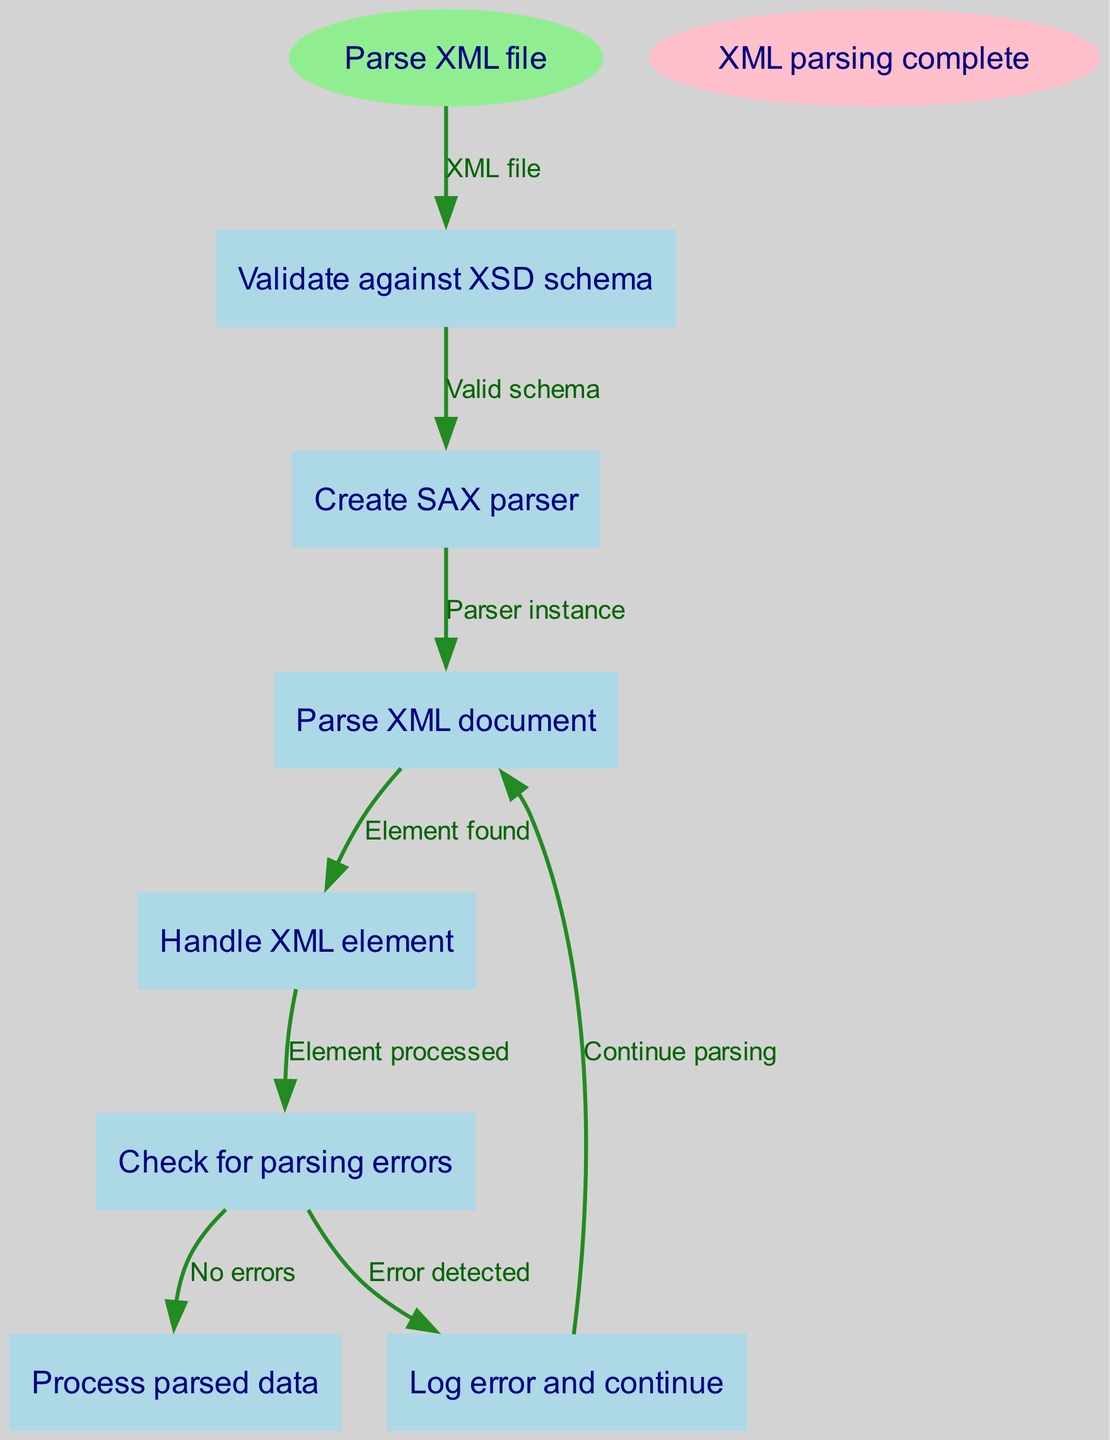What is the start point of the flow chart? The flow chart begins at the node labeled "Parse XML file." This is explicitly stated in the diagram as the entry point or starting node.
Answer: Parse XML file How many nodes are in the diagram? By counting each node listed in the diagram (including start and end nodes), we find there are a total of seven nodes: one start node, six process nodes, and one end node.
Answer: Seven What does the "Validate against XSD schema" node lead to? From the "Validate against XSD schema" node, the flow chart indicates it leads to the "Create SAX parser" node, as shown by the connecting edge labeled "Valid schema."
Answer: Create SAX parser What happens after "Check for parsing errors"? The node "Check for parsing errors" has two possible outcomes: it can lead either to "Log error and continue" if an error is detected or to "Process parsed data" if no errors are found. This bifurcation indicates a decision point based on the error-checking result.
Answer: Log error and continue or Process parsed data What is the final step of the XML parsing process? The last step in the flow of the diagram, indicated by the final node, is "XML parsing complete," which signifies that the entire parsing process has concluded successfully.
Answer: XML parsing complete What node follows the "Handle XML element" step? After "Handle XML element," the flow chart shows it directs to "Check for parsing errors." This indicates that after processing each XML element, the next step is to verify if there were any issues during parsing.
Answer: Check for parsing errors If an error is detected during parsing, where does the process go next? If an error is detected during parsing, the flow chart specifies that the process moves to "Log error and continue," allowing the parser to log the issue without halting execution.
Answer: Log error and continue How does the flow progress if there's no error found? If the parsing check reveals no errors, the process directly proceeds to "Process parsed data," allowing continuation with handling the successfully parsed content. This is shown as a direct edge leading from "Check for parsing errors" to "Process parsed data."
Answer: Process parsed data 